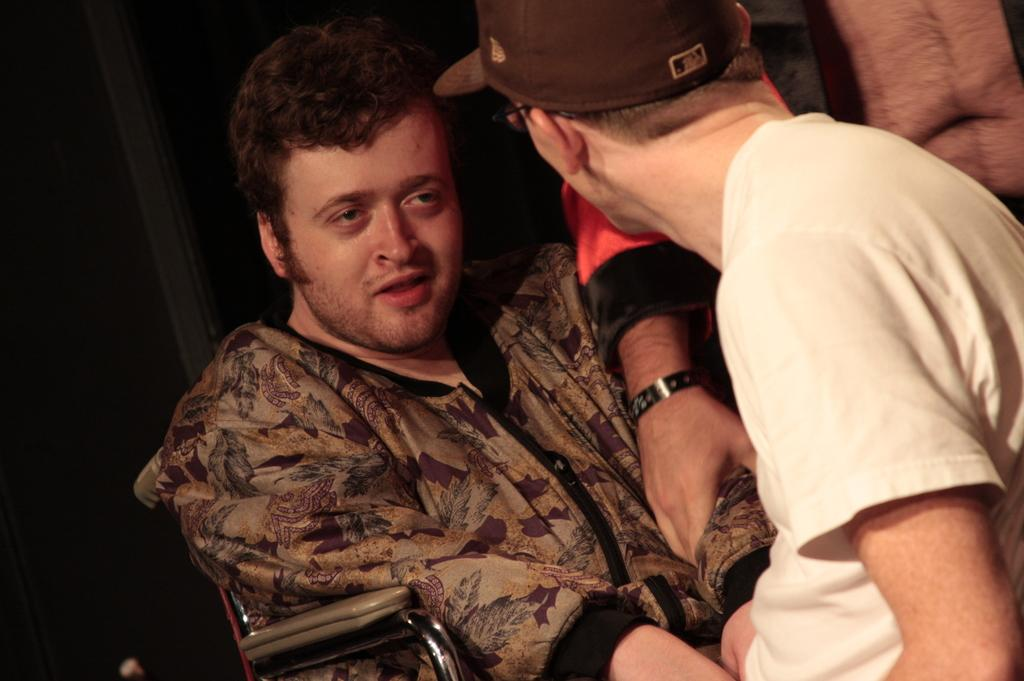What is the primary action of the person in the image? There is a person sitting on a chair in the image. Who is the sitting person looking at? The sitting person is looking at another person. What is the position of the second person in the image? There is a person standing in the image. How would you describe the lighting in the image? The background of the image is dark. What type of water feature can be seen in the image? There is no water feature present in the image. What instruments is the band playing in the image? There is no band present in the image. 